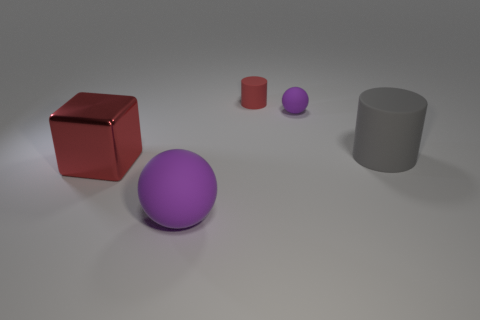What number of large metal objects have the same color as the large sphere?
Your response must be concise. 0. Is the color of the tiny cylinder the same as the big rubber sphere?
Offer a very short reply. No. What number of things are matte balls in front of the small purple object or cyan rubber things?
Ensure brevity in your answer.  1. What color is the matte thing left of the red thing to the right of the matte thing that is in front of the big cylinder?
Offer a terse response. Purple. There is another sphere that is made of the same material as the large ball; what is its color?
Offer a terse response. Purple. What number of other things are made of the same material as the big purple object?
Your answer should be very brief. 3. Is the size of the purple ball in front of the gray cylinder the same as the gray cylinder?
Keep it short and to the point. Yes. There is a matte object that is the same size as the red cylinder; what color is it?
Your response must be concise. Purple. There is a large red cube; what number of gray cylinders are behind it?
Ensure brevity in your answer.  1. Is there a sphere?
Your answer should be compact. Yes. 